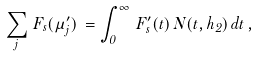Convert formula to latex. <formula><loc_0><loc_0><loc_500><loc_500>\sum _ { j } \, F _ { s } ( \mu ^ { \prime } _ { j } ) \, = \int _ { 0 } ^ { \infty } \, F ^ { \prime } _ { s } ( t ) \, N ( t , h _ { 2 } ) \, d t \, ,</formula> 